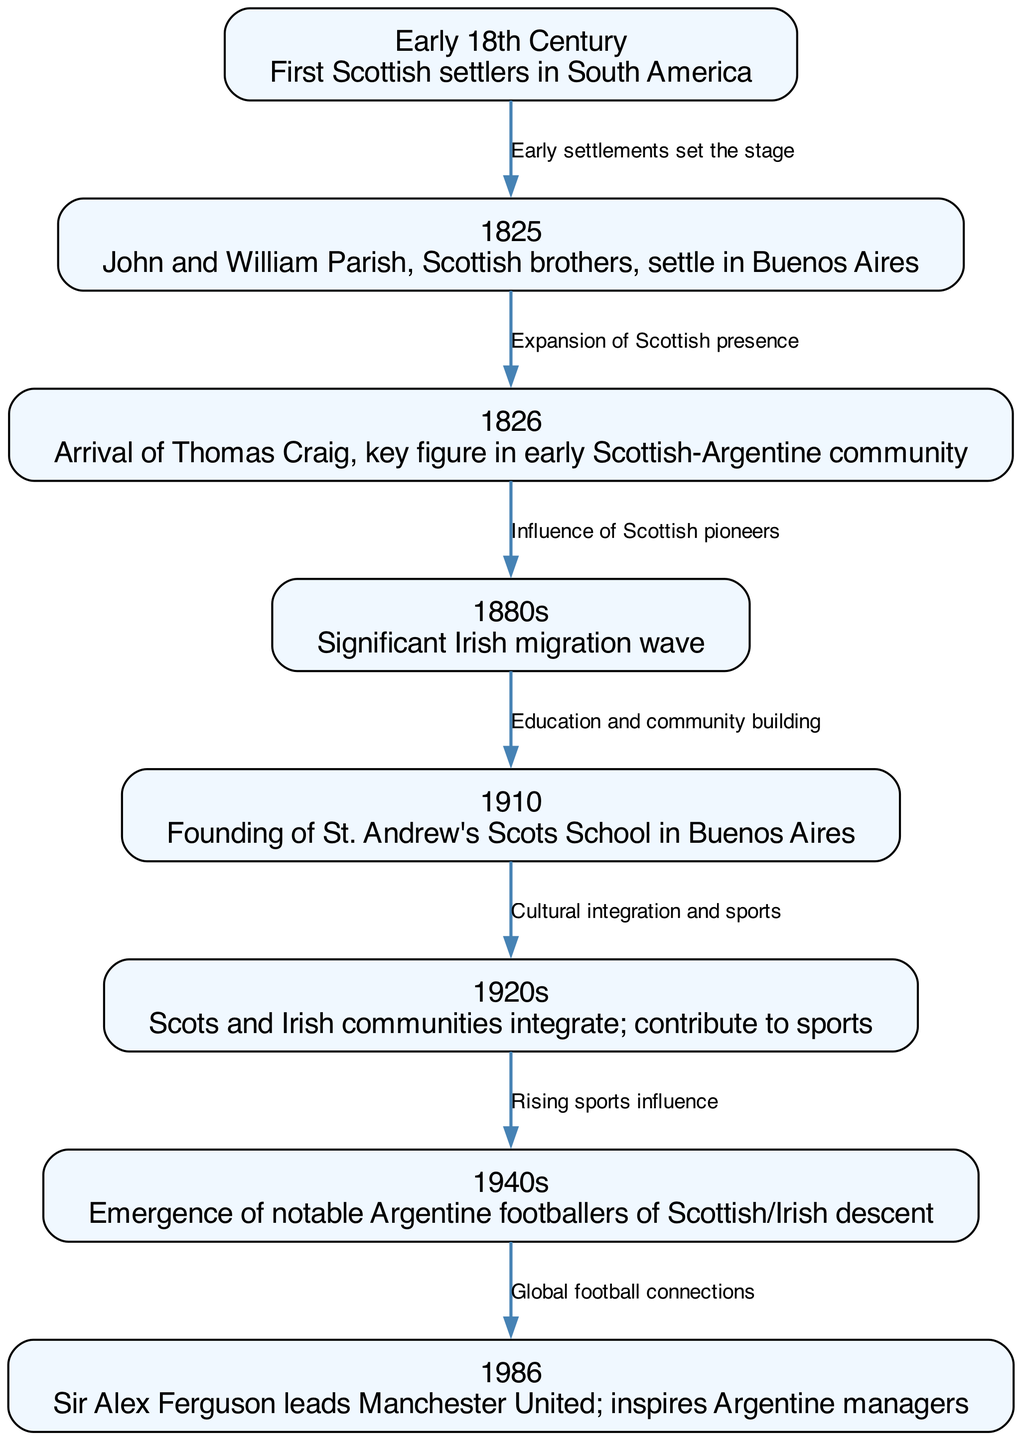What is the first event in the timeline? The first event listed in the nodes is "Early 18th Century," indicating the arrival of the first Scottish settlers in South America.
Answer: Early 18th Century How many nodes are there in the diagram? By counting the nodes listed in the data, we can identify there are eight nodes representing different key events and milestones in the migration timeline.
Answer: 8 What event follows the founding of St. Andrew's Scots School in Buenos Aires? The diagram indicates that after the founding of the school in 1910, the next event is the integration of Scots and Irish communities in the 1920s.
Answer: 1920s What was the main reason listed for the migration in the 1880s? The diagram mentions a "significant Irish migration wave" during the 1880s, indicating that this was a period characterized by substantial immigration from Ireland.
Answer: Significant Irish migration wave Which event demonstrates the cultural integration of the Scottish and Irish communities? The transition from the founding of St. Andrew's Scots School in 1910 to the 1920s shows how educational efforts contributed to the cultural integration of Scottish and Irish communities.
Answer: Cultural integration and sports What notable shift occurred in the 1940s regarding Argentine football? The diagram notes the emergence of notable Argentine footballers of Scottish/Irish descent, which indicates a significant impact of these communities in the sports arena during this period.
Answer: Emergence of notable Argentine footballers of Scottish/Irish descent How did the migration events connect to global football in 1986? The flow from the emergence of notable footballers of Scottish/Irish descent in the 1940s to Sir Alex Ferguson leading Manchester United in 1986 suggests a link between the historical migration and modern football influences.
Answer: Global football connections What is the relationship between the arrival of Thomas Craig in 1826 and the Irish migration wave in the 1880s? Thomas Craig's arrival enhances the Scottish presence, creating an environment that likely facilitated the subsequent Irish migration wave in the 1880s.
Answer: Influence of Scottish pioneers 